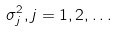<formula> <loc_0><loc_0><loc_500><loc_500>\sigma _ { j } ^ { 2 } , j = 1 , 2 , \dots</formula> 